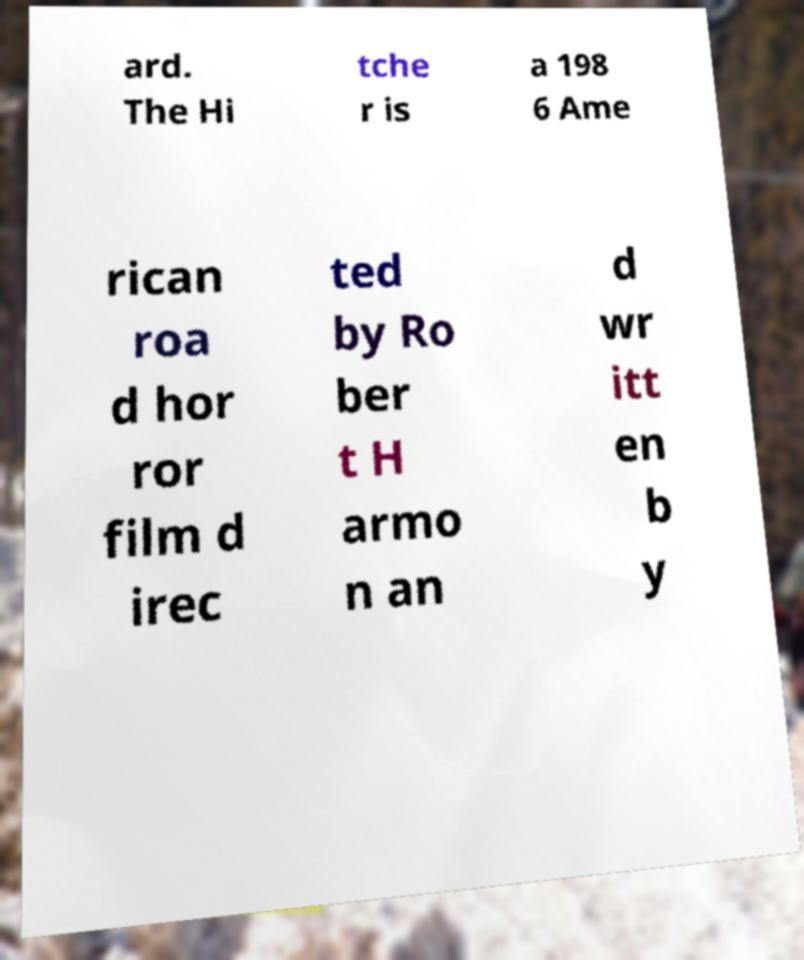I need the written content from this picture converted into text. Can you do that? ard. The Hi tche r is a 198 6 Ame rican roa d hor ror film d irec ted by Ro ber t H armo n an d wr itt en b y 